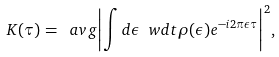<formula> <loc_0><loc_0><loc_500><loc_500>K ( \tau ) = \ a v g { \left | \int d \epsilon \ w d t { \rho } ( \epsilon ) e ^ { - i 2 \pi \epsilon \tau } \right | ^ { 2 } } ,</formula> 